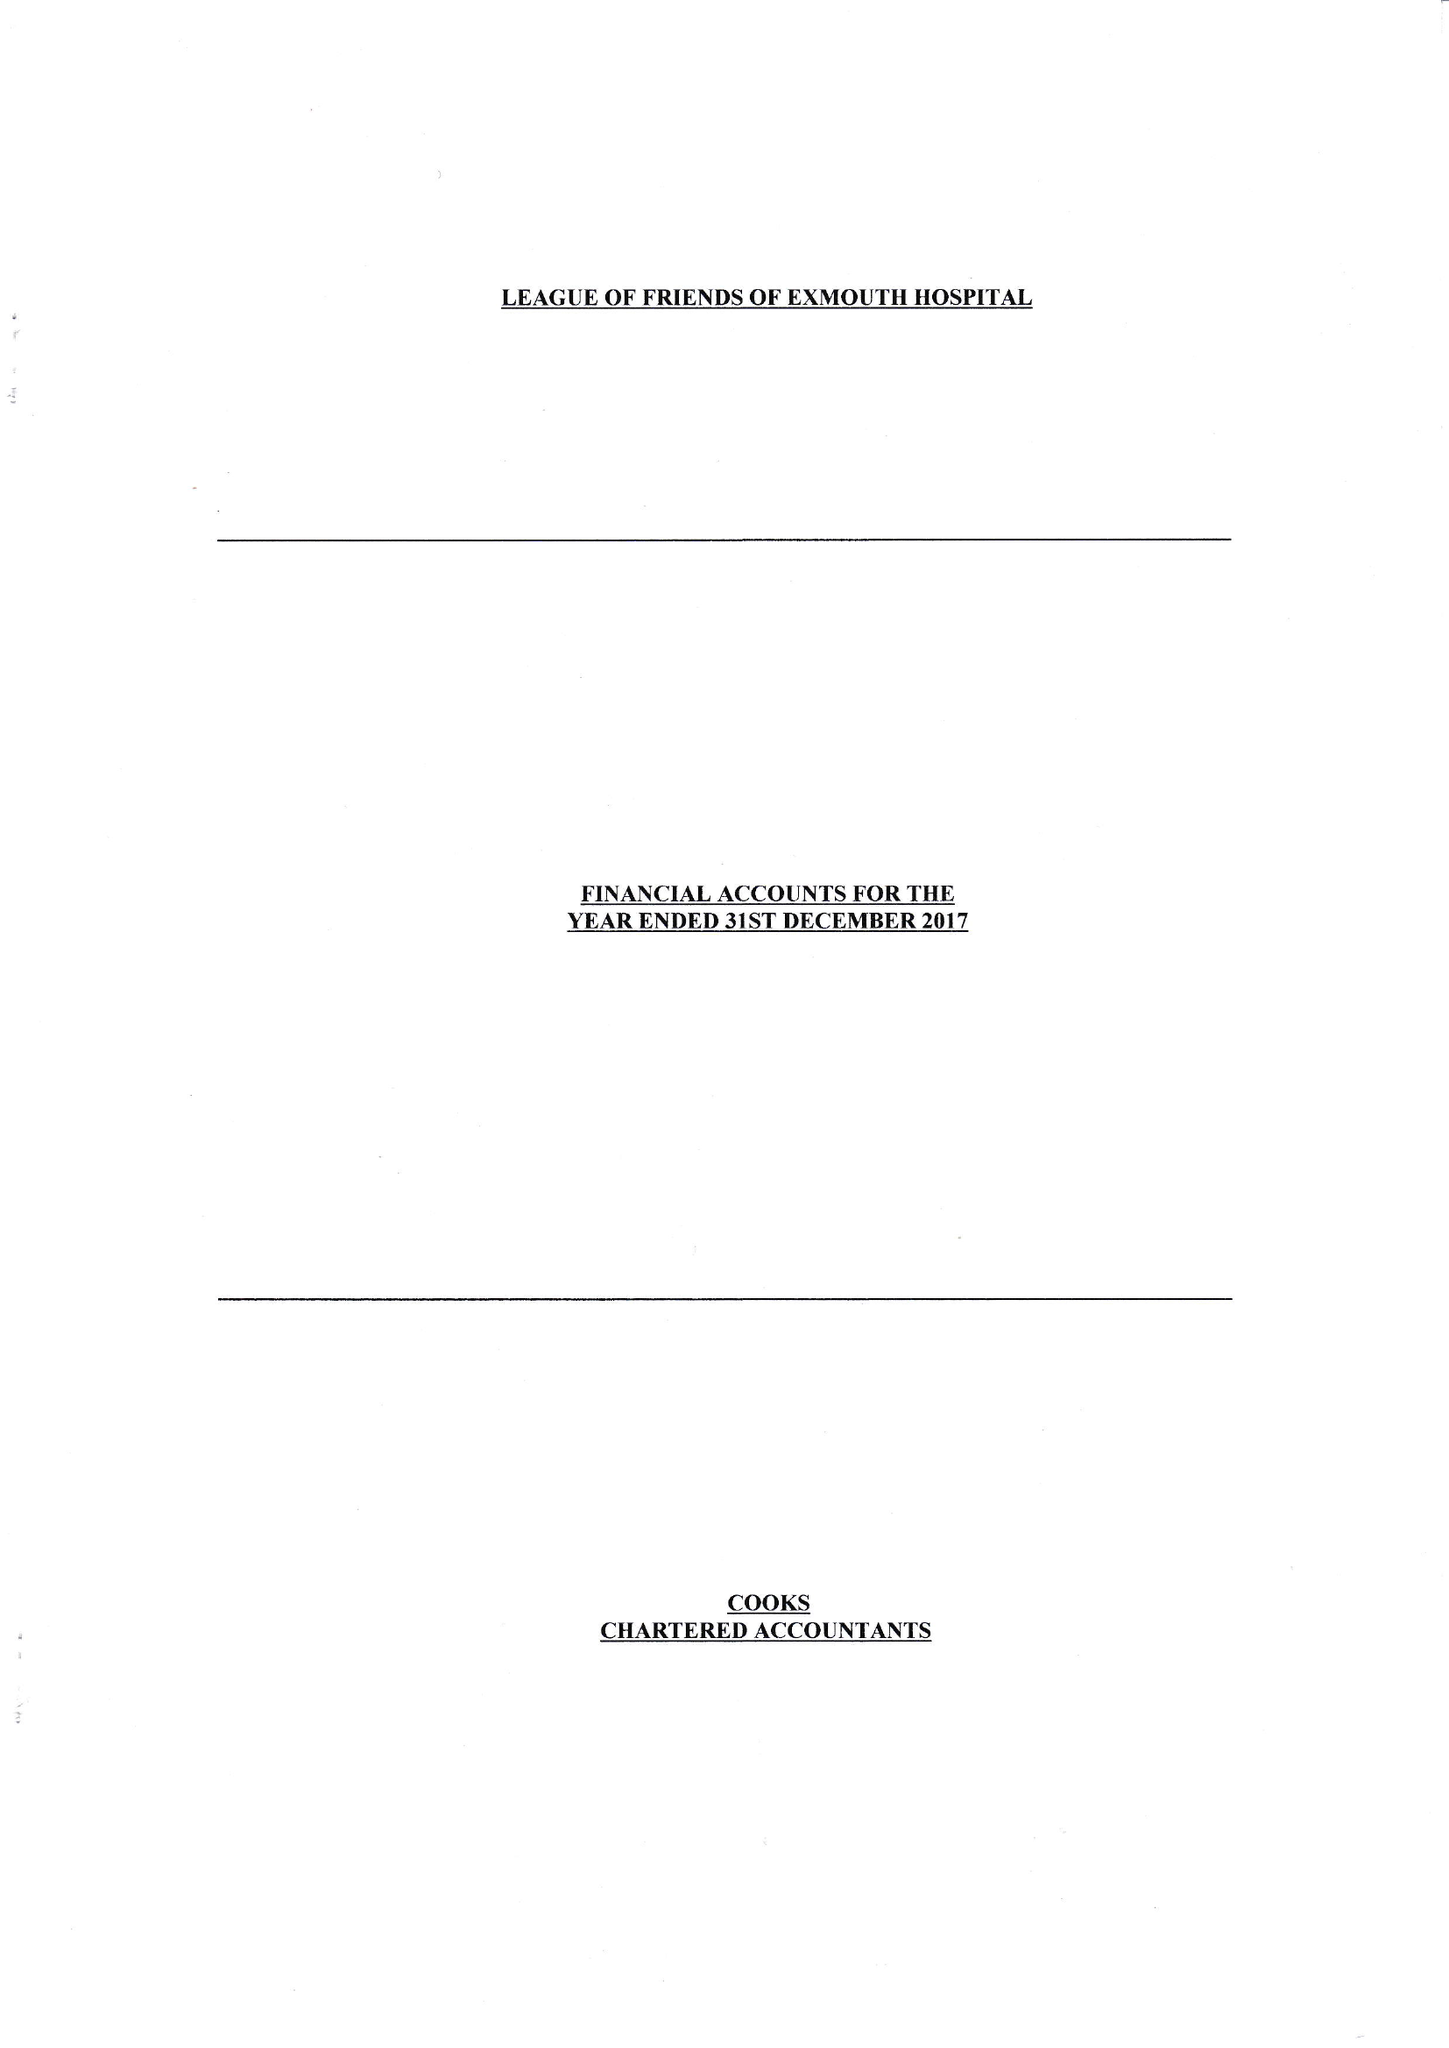What is the value for the address__post_town?
Answer the question using a single word or phrase. EXMOUTH 